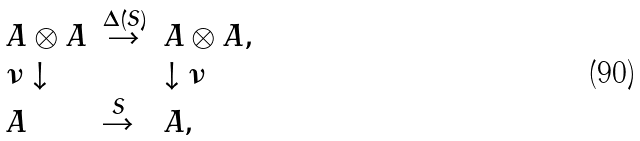Convert formula to latex. <formula><loc_0><loc_0><loc_500><loc_500>\left . \begin{array} { l l l } A \otimes A & \stackrel { \Delta ( S ) } { \rightarrow } & A \otimes A , \\ \nu \downarrow & & \downarrow \nu \\ A & \stackrel { S } { \rightarrow } & A , \end{array} \right .</formula> 